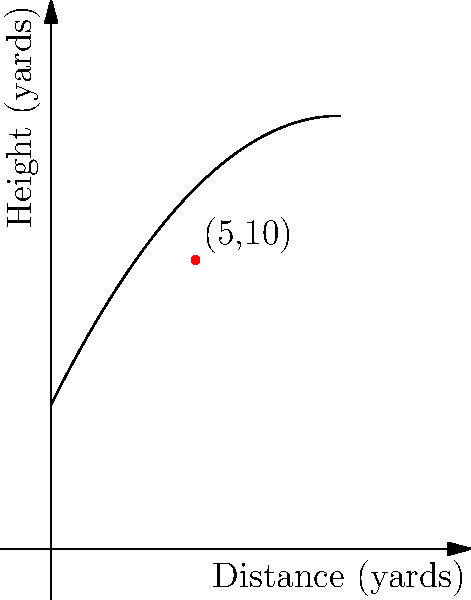As a football player, you're analyzing the trajectory of a pass. The path of the football can be modeled by the function $h(x) = -0.1x^2 + 2x + 5$, where $h$ is the height in yards and $x$ is the horizontal distance in yards. At what horizontal distance is the rate of change of the football's height equal to zero? To solve this problem, we need to follow these steps:

1) The rate of change of the football's height with respect to horizontal distance is given by the derivative of $h(x)$.

2) Let's find $h'(x)$:
   $h'(x) = -0.2x + 2$

3) We want to find where this rate of change is zero, so we set $h'(x) = 0$:
   $-0.2x + 2 = 0$

4) Solve for $x$:
   $-0.2x = -2$
   $x = \frac{-2}{-0.2} = 10$

5) Verify: 
   At $x = 10$, $h'(10) = -0.2(10) + 2 = 0$

6) Interpret the result:
   The rate of change of the football's height is zero when the horizontal distance is 10 yards. This corresponds to the peak of the parabola, where the football reaches its maximum height before beginning to descend.
Answer: 10 yards 